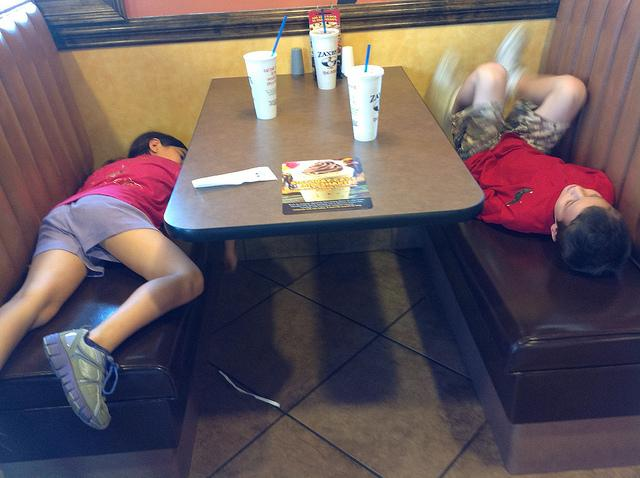Who will pay for this meal? parents 